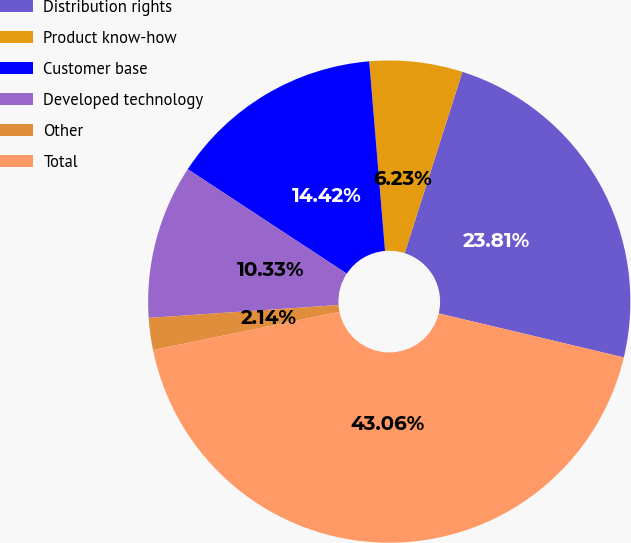<chart> <loc_0><loc_0><loc_500><loc_500><pie_chart><fcel>Distribution rights<fcel>Product know-how<fcel>Customer base<fcel>Developed technology<fcel>Other<fcel>Total<nl><fcel>23.81%<fcel>6.23%<fcel>14.42%<fcel>10.33%<fcel>2.14%<fcel>43.06%<nl></chart> 